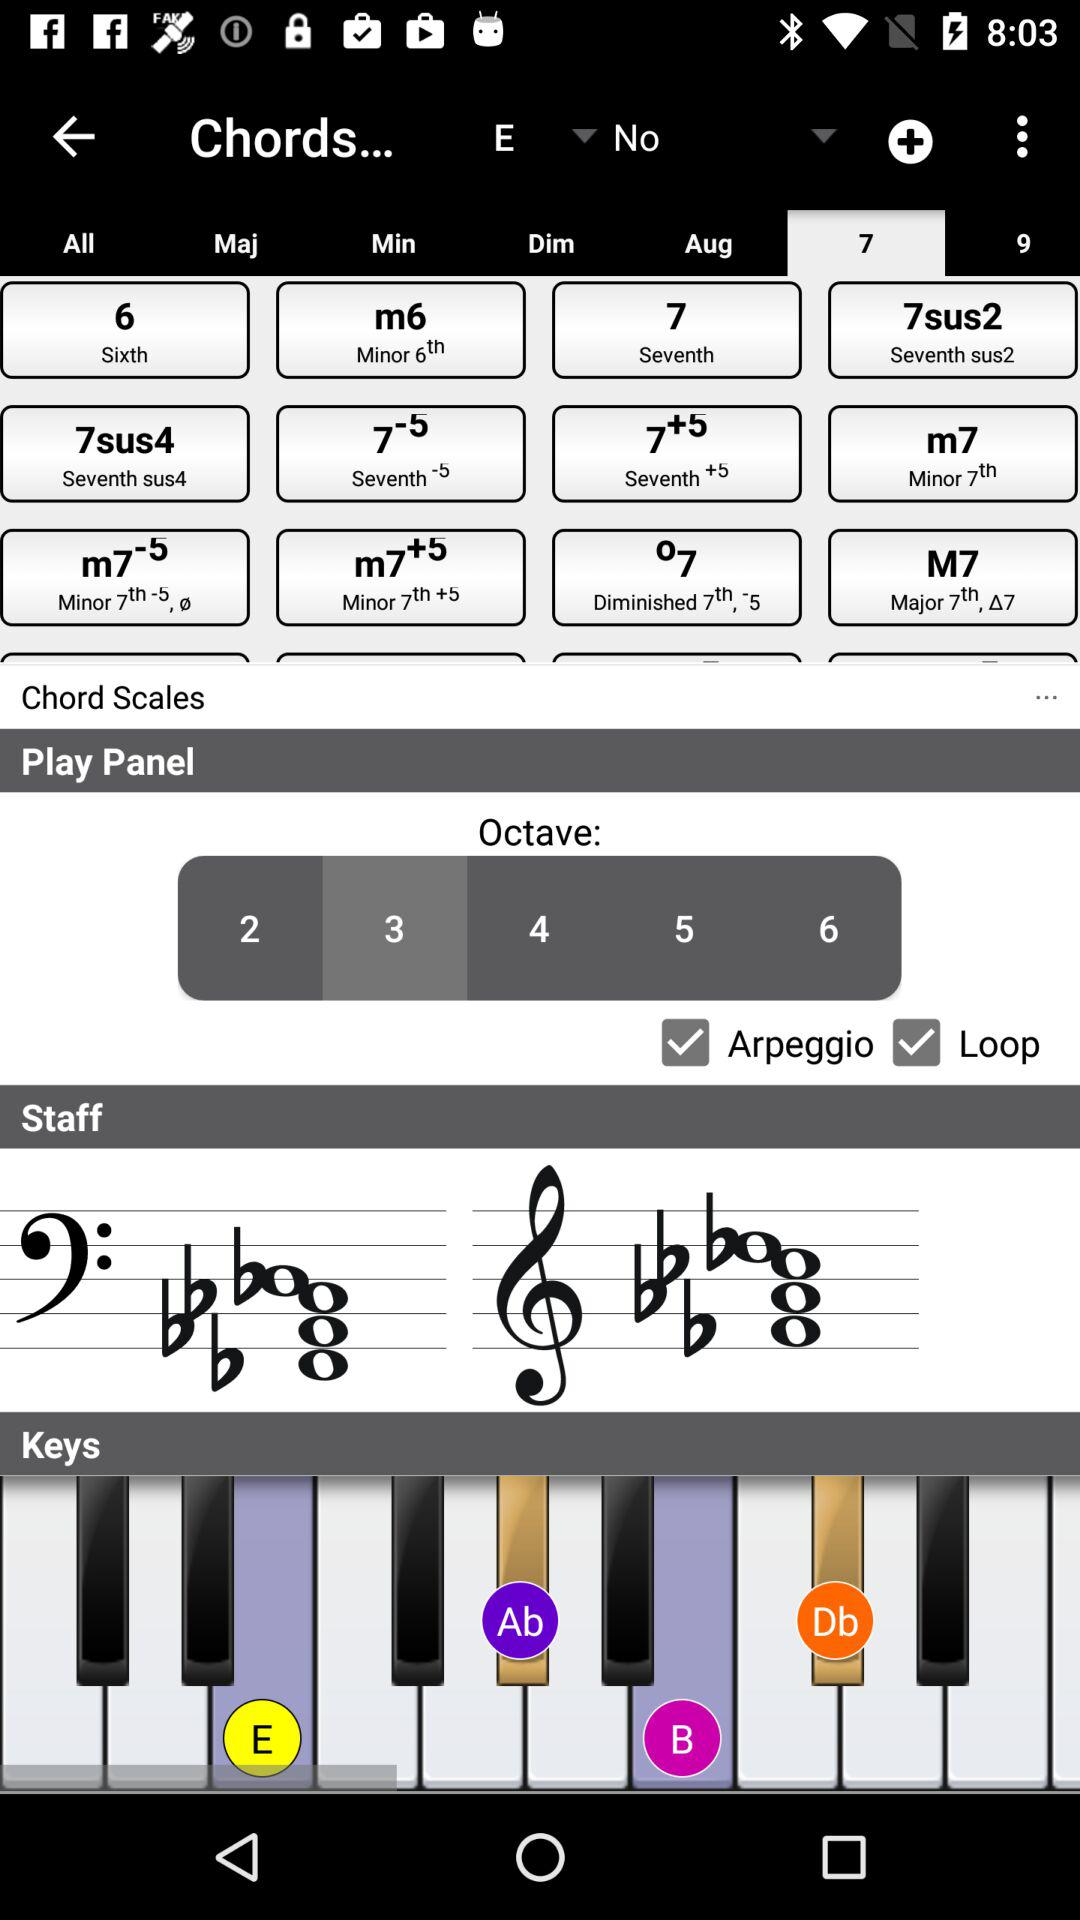What is the selected option in the Play Panel? The selected option is 3. 